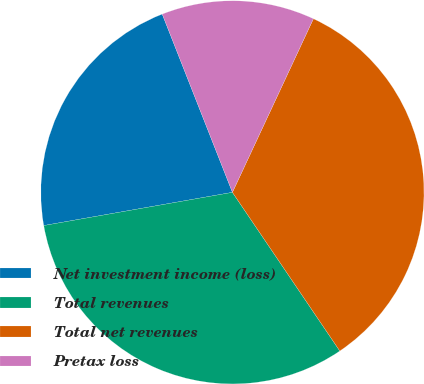Convert chart. <chart><loc_0><loc_0><loc_500><loc_500><pie_chart><fcel>Net investment income (loss)<fcel>Total revenues<fcel>Total net revenues<fcel>Pretax loss<nl><fcel>21.8%<fcel>31.7%<fcel>33.58%<fcel>12.92%<nl></chart> 